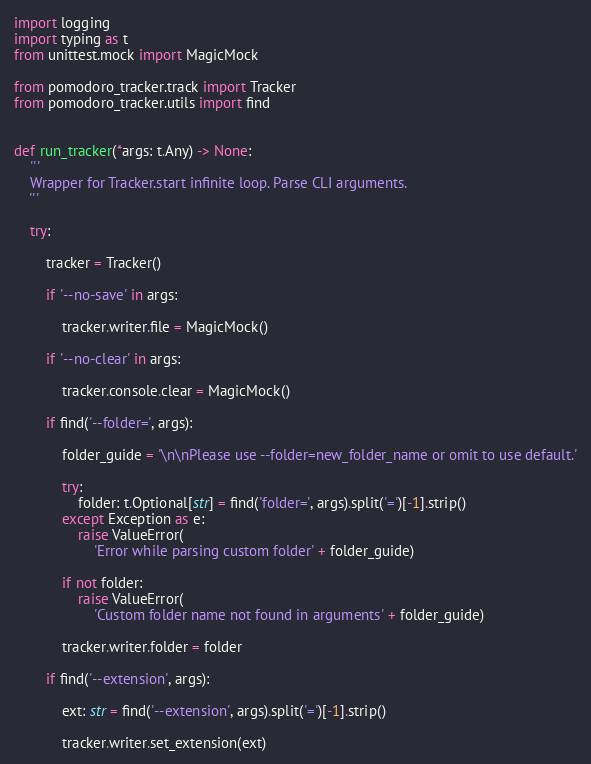Convert code to text. <code><loc_0><loc_0><loc_500><loc_500><_Python_>import logging
import typing as t
from unittest.mock import MagicMock

from pomodoro_tracker.track import Tracker
from pomodoro_tracker.utils import find


def run_tracker(*args: t.Any) -> None:
    '''
    Wrapper for Tracker.start infinite loop. Parse CLI arguments.
    '''

    try:

        tracker = Tracker()

        if '--no-save' in args:

            tracker.writer.file = MagicMock()

        if '--no-clear' in args:

            tracker.console.clear = MagicMock()

        if find('--folder=', args):

            folder_guide = '\n\nPlease use --folder=new_folder_name or omit to use default.'

            try:
                folder: t.Optional[str] = find('folder=', args).split('=')[-1].strip()
            except Exception as e:
                raise ValueError(
                    'Error while parsing custom folder' + folder_guide)

            if not folder:
                raise ValueError(
                    'Custom folder name not found in arguments' + folder_guide)

            tracker.writer.folder = folder

        if find('--extension', args):

            ext: str = find('--extension', args).split('=')[-1].strip()

            tracker.writer.set_extension(ext)
</code> 